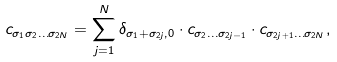Convert formula to latex. <formula><loc_0><loc_0><loc_500><loc_500>c _ { \sigma _ { 1 } \sigma _ { 2 } \dots \sigma _ { 2 N } } = \sum _ { j = 1 } ^ { N } \delta _ { \sigma _ { 1 } + \sigma _ { 2 j } , 0 } \cdot c _ { \sigma _ { 2 } \dots \sigma _ { 2 j - 1 } } \cdot c _ { \sigma _ { 2 j + 1 } \dots \sigma _ { 2 N } } ,</formula> 